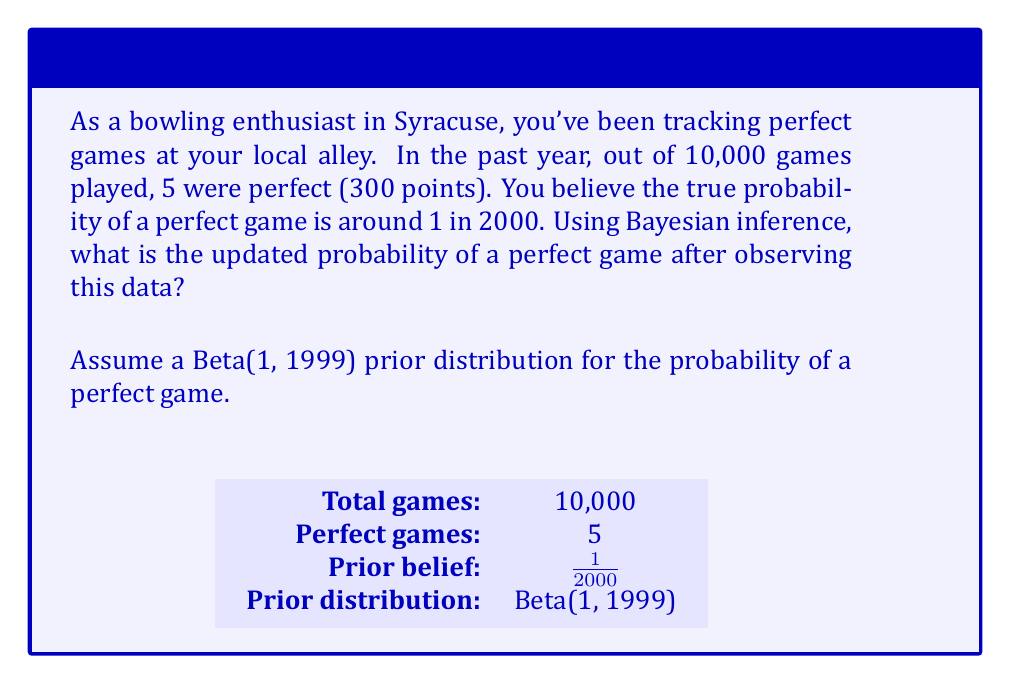Solve this math problem. Let's approach this step-by-step using Bayesian inference:

1) Our prior belief is that the probability of a perfect game is about 1 in 2000. We can model this using a Beta distribution with parameters $\alpha = 1$ and $\beta = 1999$.

2) The likelihood of our observed data (5 perfect games out of 10,000) follows a Binomial distribution.

3) In Bayesian inference, when we have a Beta prior and Binomial likelihood, the posterior distribution is also a Beta distribution. The parameters of the posterior Beta distribution are:

   $\alpha_{posterior} = \alpha_{prior} + \text{number of successes}$
   $\beta_{posterior} = \beta_{prior} + \text{number of failures}$

4) In our case:
   $\alpha_{posterior} = 1 + 5 = 6$
   $\beta_{posterior} = 1999 + (10000 - 5) = 11994$

5) The posterior distribution is therefore Beta(6, 11994).

6) The expected value of a Beta(a,b) distribution is $\frac{a}{a+b}$.

7) Therefore, our updated probability estimate is:

   $$P(\text{perfect game}) = \frac{6}{6 + 11994} = \frac{6}{12000} = 0.0005$$

This can be interpreted as 1 in 2000, which interestingly matches our prior belief.
Answer: 0.0005 or 1/2000 